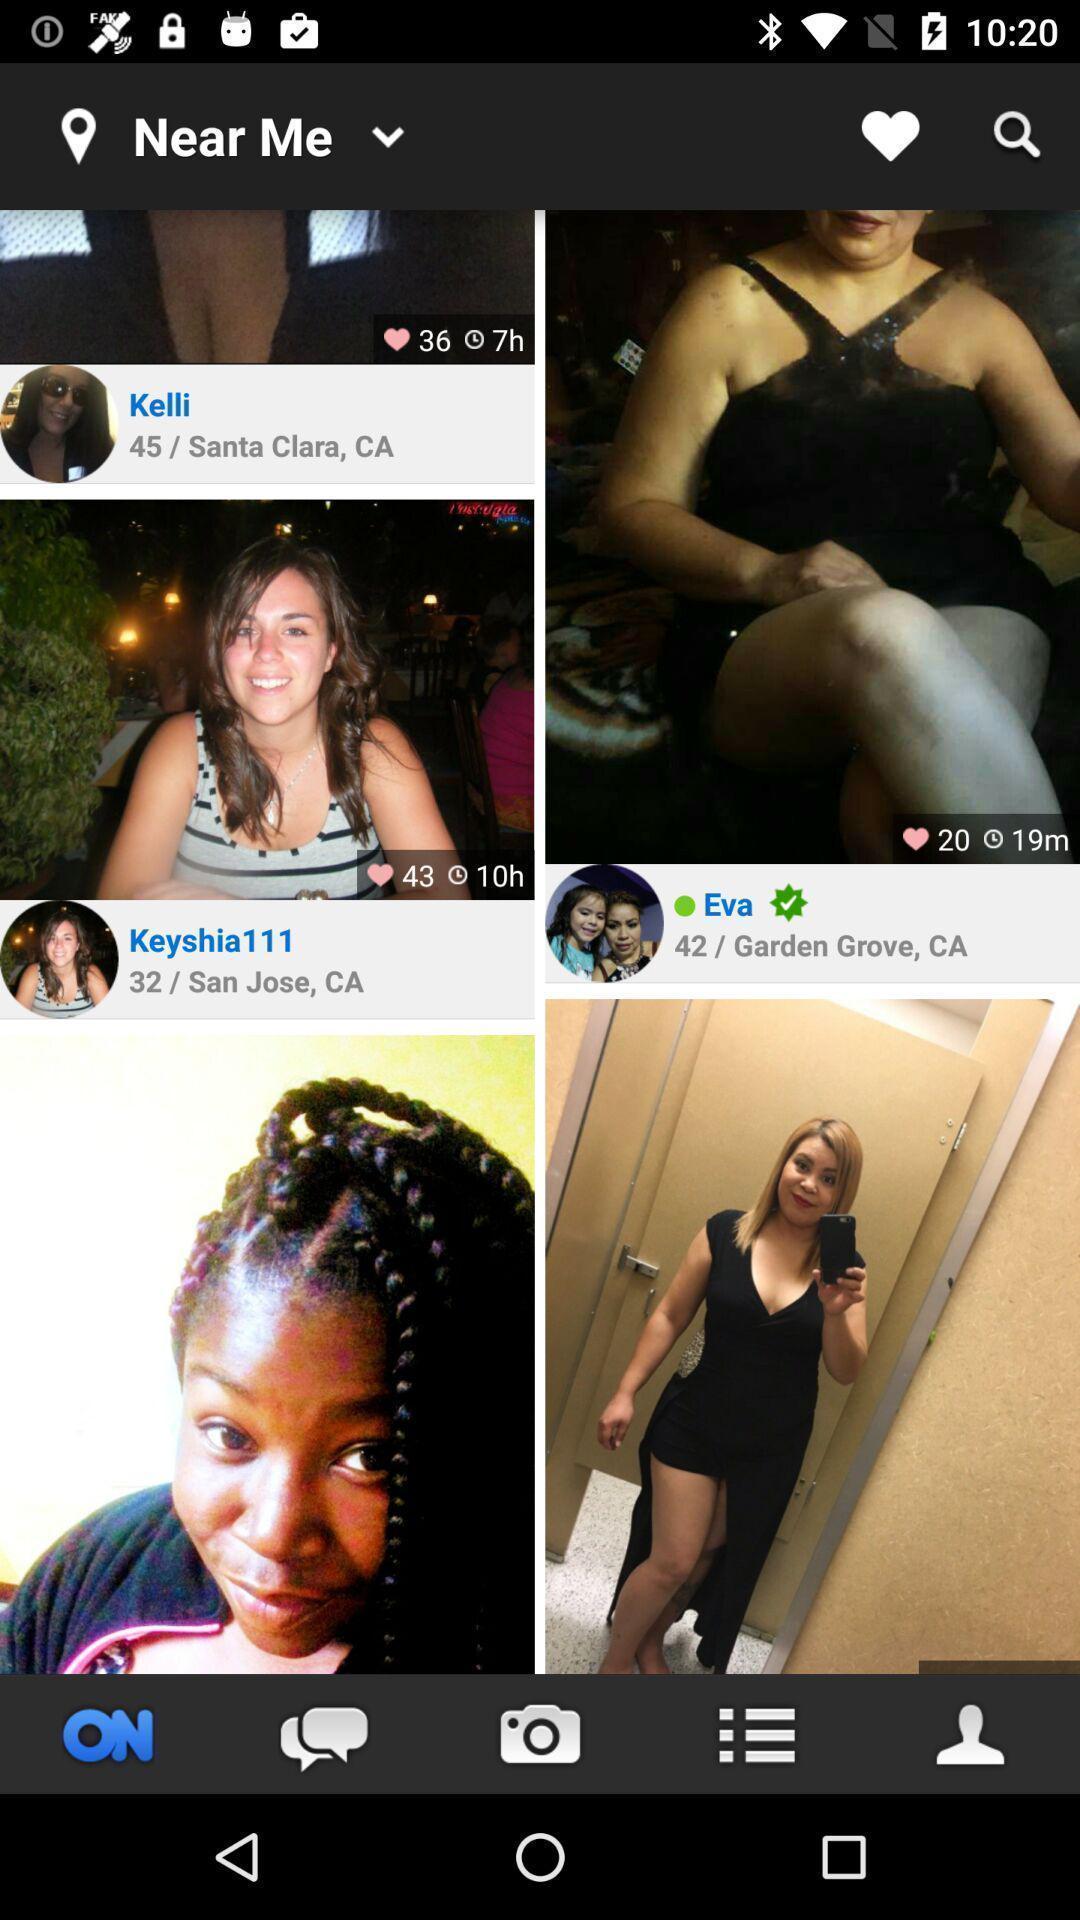Please provide a description for this image. Screen showing profiles near me. 